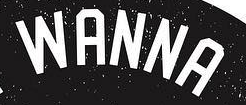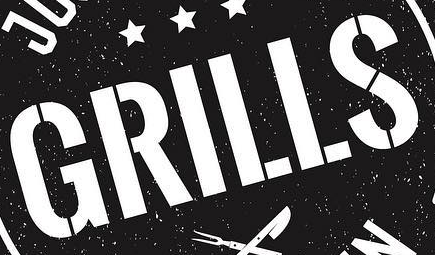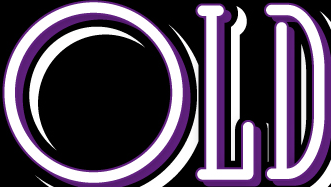What words are shown in these images in order, separated by a semicolon? WANNA; GRILLS; OLD 